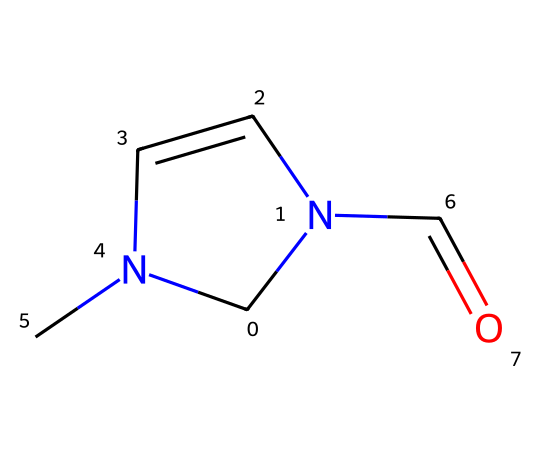What is the total number of atoms in this chemical? To determine the total number of atoms, count each atom type present in the SMILES representation. There are 6 Carbon (C) atoms, 2 Nitrogen (N) atoms, and 1 Oxygen (O) atom, giving a total of 6 + 2 + 1 = 9 atoms.
Answer: 9 How many double bonds are present in this chemical? Looking at the Euler structure of the SMILES representation, one can see that there are 2 instances of double bonds: one between a Carbon and a Nitrogen (C=N), and one between a Carbon and an Oxygen (C=O). Therefore, there are a total of 2 double bonds.
Answer: 2 What is the functional group present in this structure? Analyzing the structure, the presence of the carbonyl group (C=O) indicates that the functional group is an aldehyde, shown by the carbon bound to the nitrogen and the carbonyl oxygen.
Answer: aldehyde What type of catalyst can this carbene act as in industrial processes? This carbene structure allows it to function as a catalytic intermediate in several reactions, specifically as a carbene catalyst in cyclopropanation and other organic transformations.
Answer: carbene catalyst Is there a possibility for this compound to participate in catalytic cycles? Yes, given that carbenes are known for their ability to insert into bonds and facilitate reactions, this compound can participate in catalytic cycles in organic synthesis.
Answer: Yes What type of reaction can be facilitated by this carbene structure? The presence of both nitrogen and carbon functionalities suggests this carbene can facilitate reactions such as nucleophilic addition or cycloaddition.
Answer: nucleophilic addition What role do the nitrogen atoms play in this compound? The nitrogen atoms stabilize the carbene structure and may also influence its reactivity by participating in coordination with substrates in catalytic processes.
Answer: stabilization 